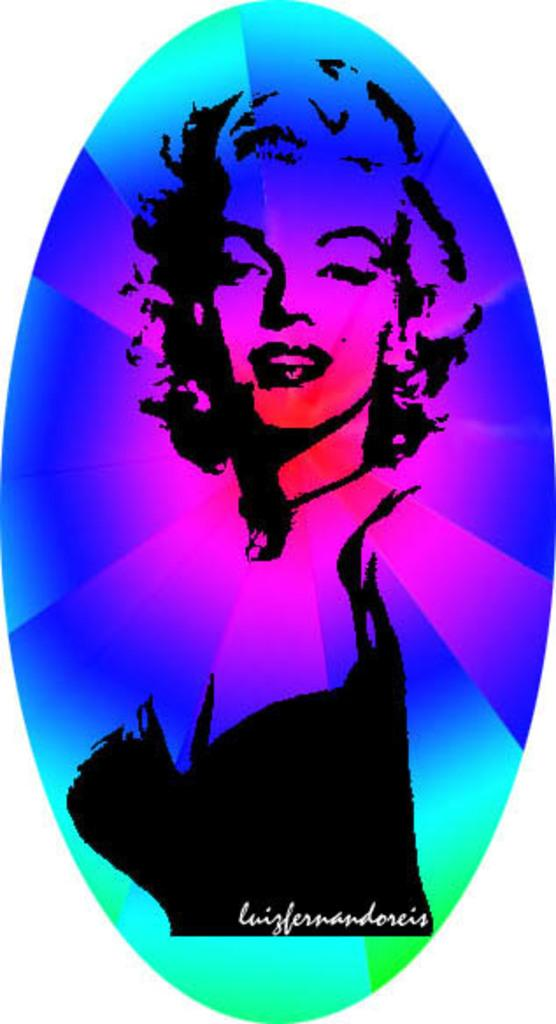What type of image is shown? The image is a colorful graphic picture. What is the main subject of the image? The picture depicts a lady. Are there any words or letters on the image? Yes, there is text present on the image. Where is the record player located in the image? There is no record player present in the image. What type of mint plant can be seen growing in the image? There is no mint plant present in the image. 